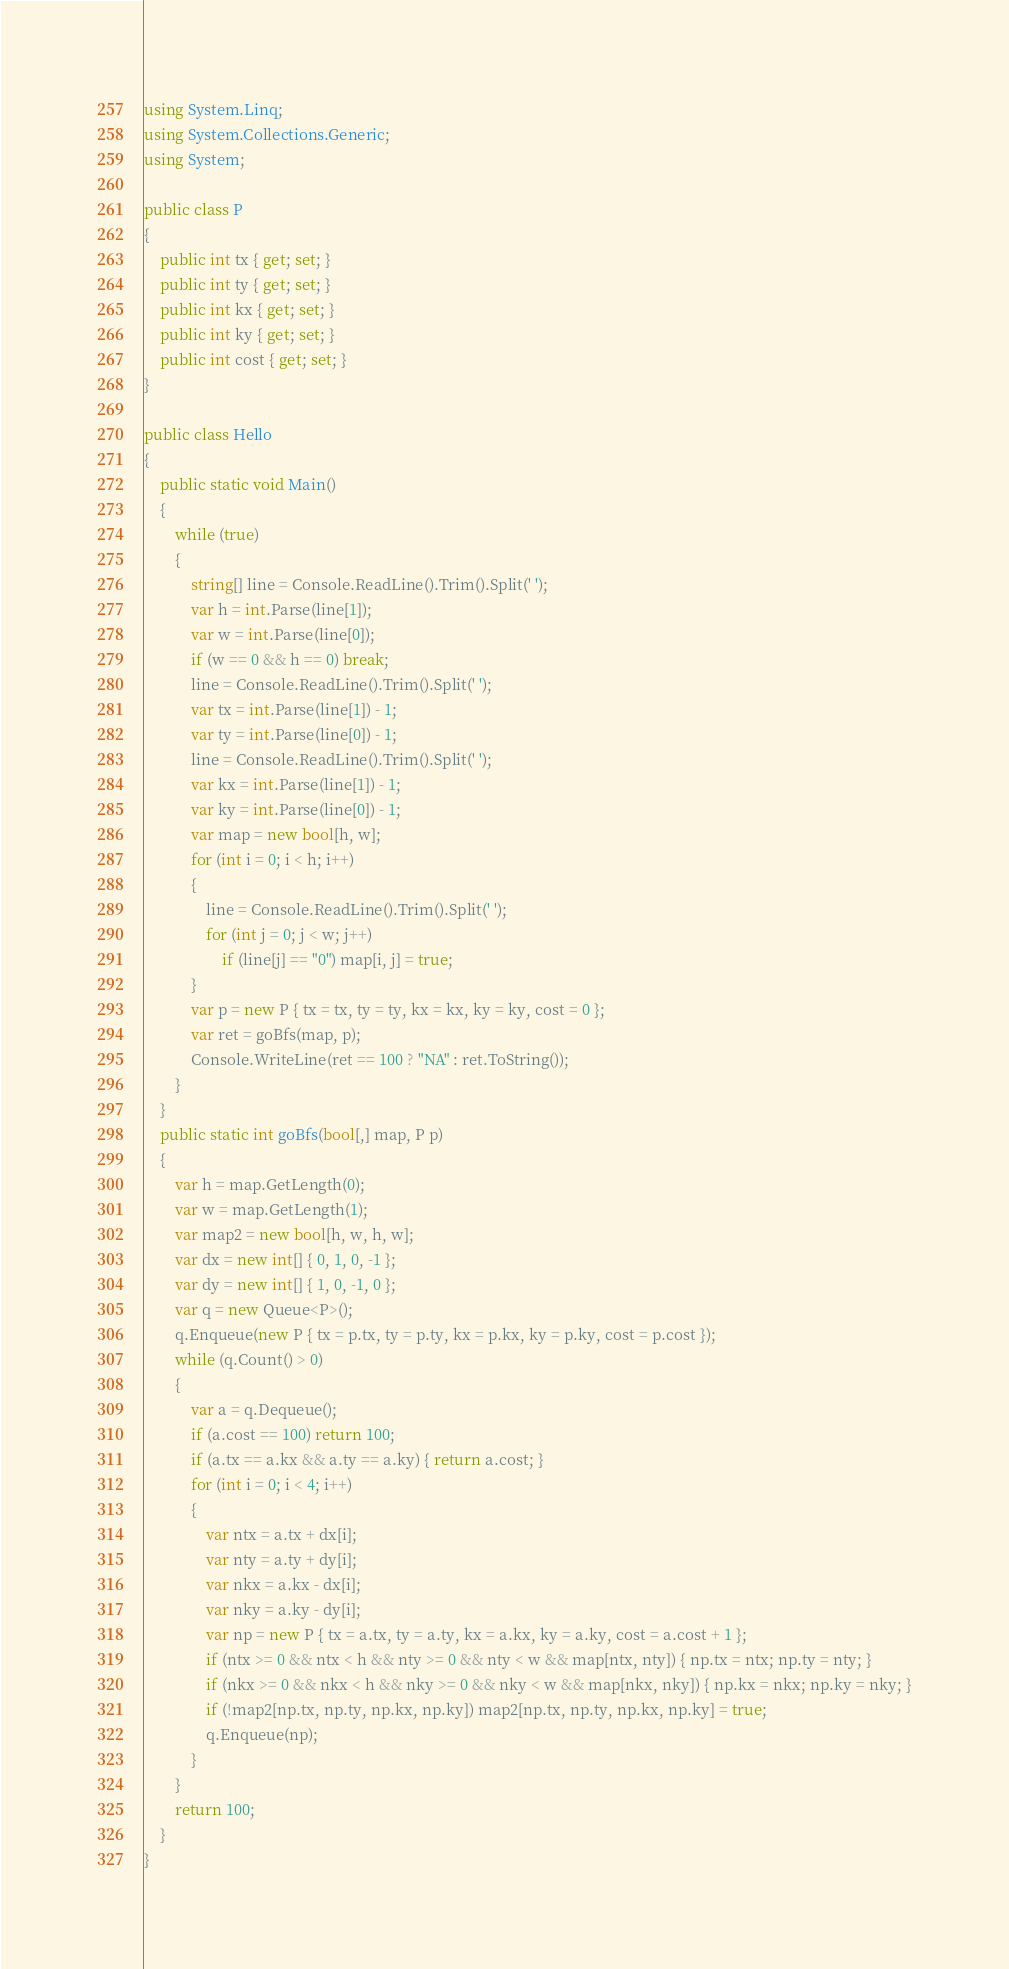<code> <loc_0><loc_0><loc_500><loc_500><_C#_>using System.Linq;
using System.Collections.Generic;
using System;

public class P
{
    public int tx { get; set; }
    public int ty { get; set; }
    public int kx { get; set; }
    public int ky { get; set; }
    public int cost { get; set; }
}

public class Hello
{
    public static void Main()
    {
        while (true)
        {
            string[] line = Console.ReadLine().Trim().Split(' ');
            var h = int.Parse(line[1]);
            var w = int.Parse(line[0]);
            if (w == 0 && h == 0) break;
            line = Console.ReadLine().Trim().Split(' ');
            var tx = int.Parse(line[1]) - 1;
            var ty = int.Parse(line[0]) - 1;
            line = Console.ReadLine().Trim().Split(' ');
            var kx = int.Parse(line[1]) - 1;
            var ky = int.Parse(line[0]) - 1;
            var map = new bool[h, w];
            for (int i = 0; i < h; i++)
            {
                line = Console.ReadLine().Trim().Split(' ');
                for (int j = 0; j < w; j++)
                    if (line[j] == "0") map[i, j] = true;
            }
            var p = new P { tx = tx, ty = ty, kx = kx, ky = ky, cost = 0 };
            var ret = goBfs(map, p);
            Console.WriteLine(ret == 100 ? "NA" : ret.ToString());
        }
    }
    public static int goBfs(bool[,] map, P p)
    {
        var h = map.GetLength(0);
        var w = map.GetLength(1);
        var map2 = new bool[h, w, h, w];
        var dx = new int[] { 0, 1, 0, -1 };
        var dy = new int[] { 1, 0, -1, 0 };
        var q = new Queue<P>();
        q.Enqueue(new P { tx = p.tx, ty = p.ty, kx = p.kx, ky = p.ky, cost = p.cost });
        while (q.Count() > 0)
        {
            var a = q.Dequeue();
            if (a.cost == 100) return 100;
            if (a.tx == a.kx && a.ty == a.ky) { return a.cost; }
            for (int i = 0; i < 4; i++)
            {
                var ntx = a.tx + dx[i];
                var nty = a.ty + dy[i];
                var nkx = a.kx - dx[i];
                var nky = a.ky - dy[i];
                var np = new P { tx = a.tx, ty = a.ty, kx = a.kx, ky = a.ky, cost = a.cost + 1 };
                if (ntx >= 0 && ntx < h && nty >= 0 && nty < w && map[ntx, nty]) { np.tx = ntx; np.ty = nty; }
                if (nkx >= 0 && nkx < h && nky >= 0 && nky < w && map[nkx, nky]) { np.kx = nkx; np.ky = nky; }
                if (!map2[np.tx, np.ty, np.kx, np.ky]) map2[np.tx, np.ty, np.kx, np.ky] = true;
                q.Enqueue(np);
            }
        }
        return 100;
    }
}




</code> 